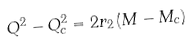Convert formula to latex. <formula><loc_0><loc_0><loc_500><loc_500>Q ^ { 2 } - Q _ { c } ^ { 2 } = 2 r _ { 2 } \left ( M - M _ { c } \right )</formula> 